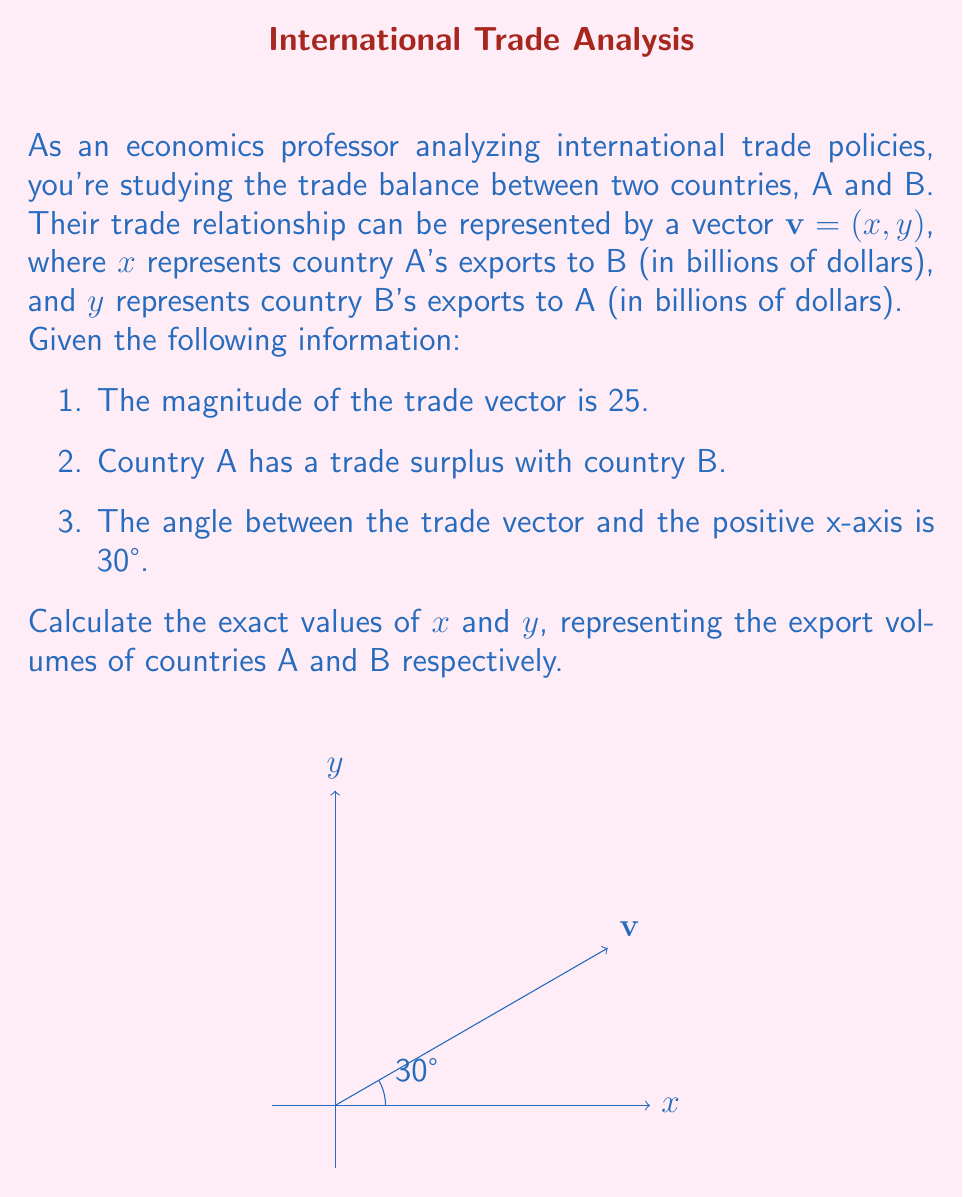Help me with this question. Let's approach this step-by-step:

1) We know that the magnitude of the vector is 25. This gives us our first equation:

   $$ \|\mathbf{v}\| = \sqrt{x^2 + y^2} = 25 $$

2) We're told that the angle between the vector and the positive x-axis is 30°. We can use trigonometric ratios to set up two more equations:

   $\cos 30° = \frac{x}{25}$ and $\sin 30° = \frac{y}{25}$

3) Let's solve for x using the cosine equation:
   
   $x = 25 \cos 30° = 25 \cdot \frac{\sqrt{3}}{2} = \frac{25\sqrt{3}}{2} \approx 21.65$

4) Now, let's solve for y using the sine equation:
   
   $y = 25 \sin 30° = 25 \cdot \frac{1}{2} = \frac{25}{2} = 12.5$

5) We can verify that these values satisfy our original magnitude equation:

   $\sqrt{(\frac{25\sqrt{3}}{2})^2 + (12.5)^2} = \sqrt{468.75 + 156.25} = \sqrt{625} = 25$

6) Lastly, we need to check if this satisfies the condition that country A has a trade surplus. Since $x > y$, this condition is met.

Therefore, country A exports $\frac{25\sqrt{3}}{2}$ billion dollars to country B, and country B exports $\frac{25}{2}$ billion dollars to country A.
Answer: $x = \frac{25\sqrt{3}}{2}$, $y = \frac{25}{2}$ 